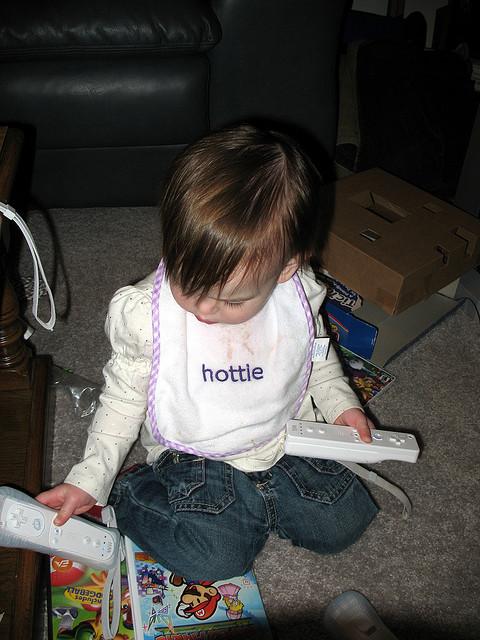Is the child wearing a bib?
Keep it brief. Yes. What is in the baby's right hand?
Quick response, please. Wii remote. Are the little girls feet touching the ground?
Answer briefly. Yes. What is the child holding in its hands?
Give a very brief answer. Wii controllers. What is the baby holding?
Keep it brief. Controller. What is she wearing around her neck?
Give a very brief answer. Bib. Is there any carpet on the floor?
Write a very short answer. Yes. What is the child holding?
Answer briefly. Wii remote. What does her shirt say?
Keep it brief. Hottie. What is this baby doing?
Be succinct. Playing. 